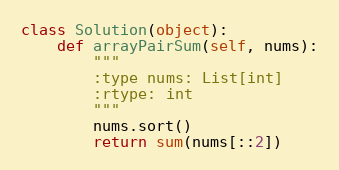Convert code to text. <code><loc_0><loc_0><loc_500><loc_500><_Python_>class Solution(object):
    def arrayPairSum(self, nums):
        """
        :type nums: List[int]
        :rtype: int
        """
        nums.sort()
        return sum(nums[::2])</code> 